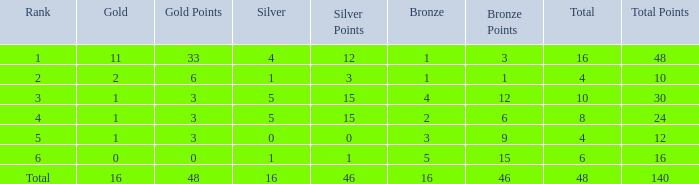How many gold are a rank 1 and larger than 16? 0.0. 